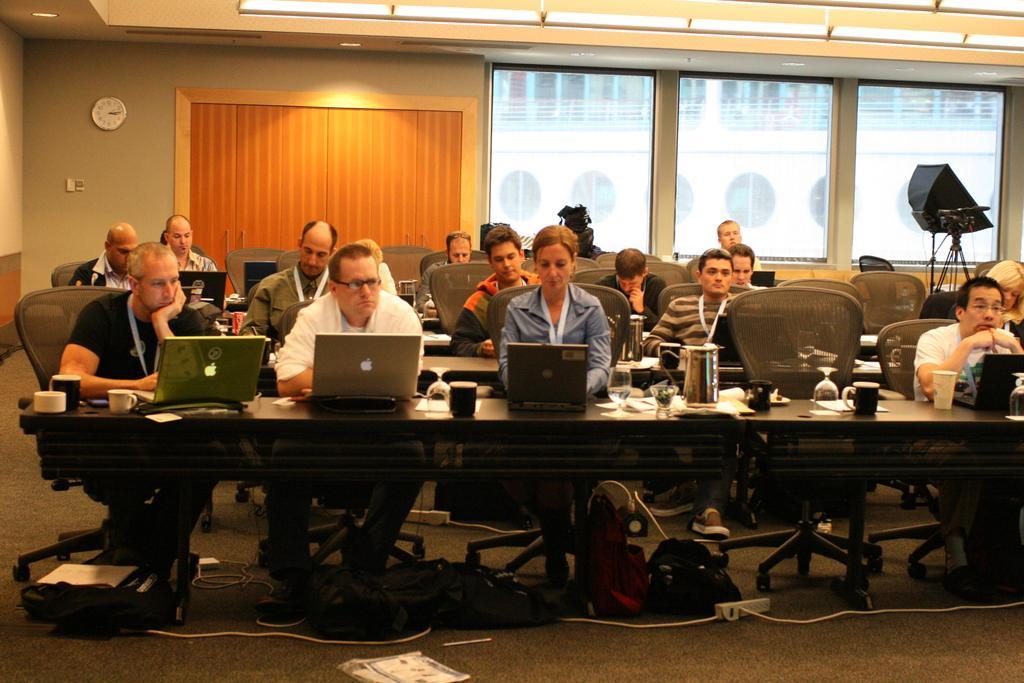How would you summarize this image in a sentence or two? On the background of the picture we can see a door, window, wall, clock. Here we can see few persons sitting on the chairs in front of a table and on the table we can see cup, glasses, jar, laptops and under the table we can see bags. This is a socket. This is a floor. 